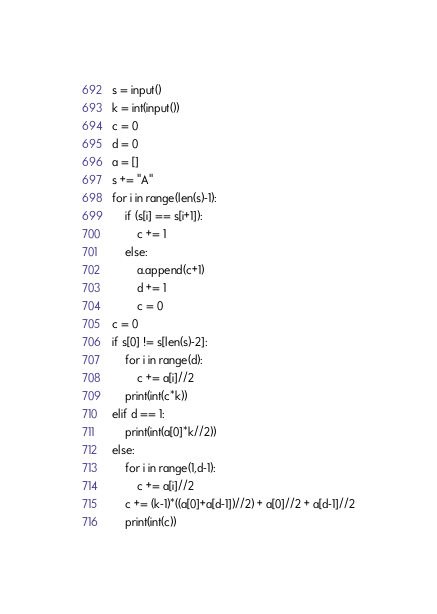<code> <loc_0><loc_0><loc_500><loc_500><_Python_>s = input()
k = int(input())
c = 0
d = 0
a = []
s += "A"
for i in range(len(s)-1):
    if (s[i] == s[i+1]):
        c += 1
    else:
        a.append(c+1)
        d += 1
        c = 0
c = 0
if s[0] != s[len(s)-2]:
    for i in range(d):
        c += a[i]//2
    print(int(c*k))
elif d == 1:
    print(int(a[0]*k//2))
else:
    for i in range(1,d-1):
        c += a[i]//2
    c += (k-1)*((a[0]+a[d-1])//2) + a[0]//2 + a[d-1]//2
    print(int(c))
</code> 